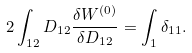<formula> <loc_0><loc_0><loc_500><loc_500>2 \int _ { 1 2 } D _ { 1 2 } \frac { \delta W ^ { ( 0 ) } } { \delta D _ { 1 2 } } = \int _ { 1 } \delta _ { 1 1 } .</formula> 